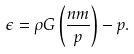Convert formula to latex. <formula><loc_0><loc_0><loc_500><loc_500>\epsilon = \rho G \left ( \frac { n m } { p } \right ) - p .</formula> 